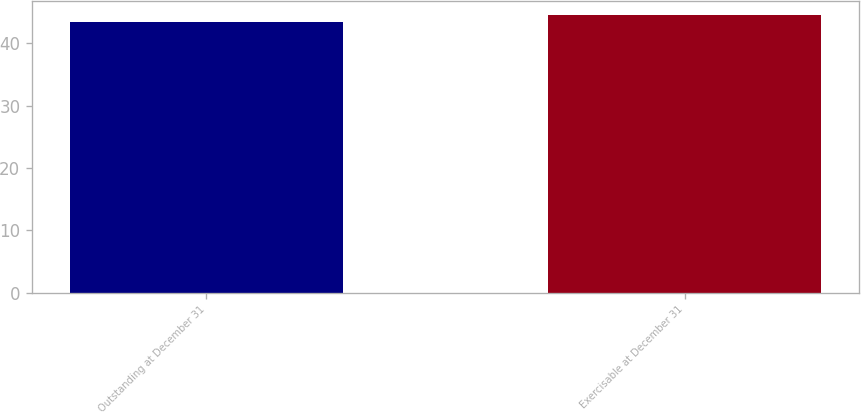Convert chart to OTSL. <chart><loc_0><loc_0><loc_500><loc_500><bar_chart><fcel>Outstanding at December 31<fcel>Exercisable at December 31<nl><fcel>43.49<fcel>44.54<nl></chart> 